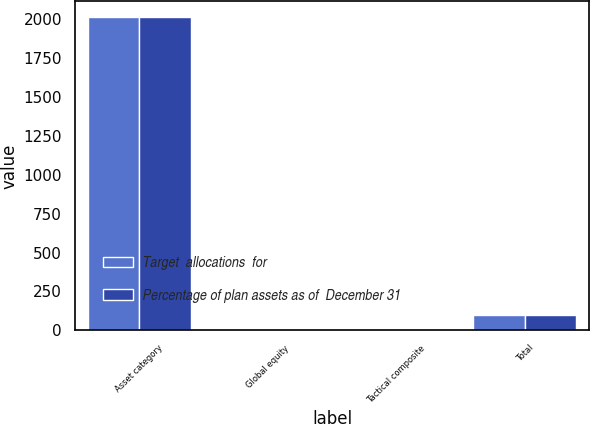Convert chart to OTSL. <chart><loc_0><loc_0><loc_500><loc_500><stacked_bar_chart><ecel><fcel>Asset category<fcel>Global equity<fcel>Tactical composite<fcel>Total<nl><fcel>Target  allocations  for<fcel>2014<fcel>0<fcel>0<fcel>100<nl><fcel>Percentage of plan assets as of  December 31<fcel>2013<fcel>0<fcel>0<fcel>100<nl></chart> 